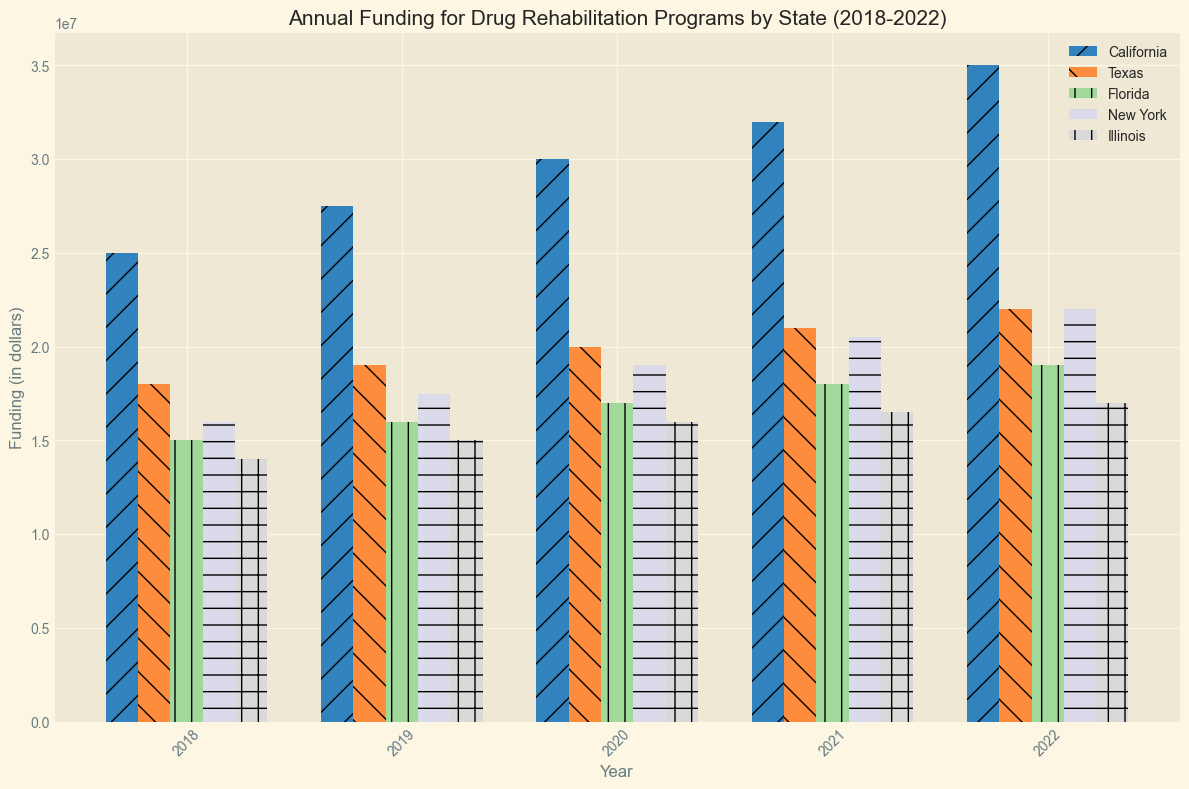What state received the highest funding in 2022? Look at the height of the bars for 2022 across all states and identify which is the tallest. California has the highest bar for 2022.
Answer: California Which state had the lowest increase in funding from 2018 to 2022? Calculate the difference in funding between 2018 and 2022 for each state. Illinois increased from $14,000,000 to $17,000,000, which is the smallest increase.
Answer: Illinois How much total funding was allocated to drug rehabilitation programs in California over the five years? Sum up the annual funding amounts for California from 2018 to 2022. The amounts are $25,000,000 + $27,500,000 + $30,000,000 + $32,000,000 + $35,000,000.
Answer: $149,500,000 Which two states had the closest funding amounts in 2020? Compare the heights of the bars for 2020 across all states to see which ones are closest. Texas and New York both had $19,000,000 in funding for 2020.
Answer: Texas and New York By what percentage did Texas's funding increase from 2018 to 2022? Calculate the percentage increase from 2018 to 2022 for Texas using the formula: ((Value_2022 - Value_2018) / Value_2018) * 100. Texas's funding increased from $18,000,000 to $22,000,000. The calculation is (($22,000,000 - $18,000,000) / $18,000,000) * 100.
Answer: 22.22% What is the average annual funding for Florida over the five-year period? Calculate the average of the funding values for Florida from 2018 to 2022. The amounts are $15,000,000, $16,000,000, $17,000,000, $18,000,000, and $19,000,000. The average is the total sum divided by 5.
Answer: $17,000,000 Which year had the highest total funding across all states? Sum the funding amounts for all states in each year and compare. Sum for 2022: $35,000,000 (CA) + $22,000,000 (TX) + $19,000,000 (FL) + $22,000,000 (NY) + $17,000,000 (IL) = $115,000,000. Other years have lower sums, so 2022 is highest.
Answer: 2022 What was the difference in funding between California and Florida in 2018? Subtract Florida's 2018 funding from California's 2018 funding. California had $25,000,000, and Florida had $15,000,000. The difference is $25,000,000 - $15,000,000.
Answer: $10,000,000 